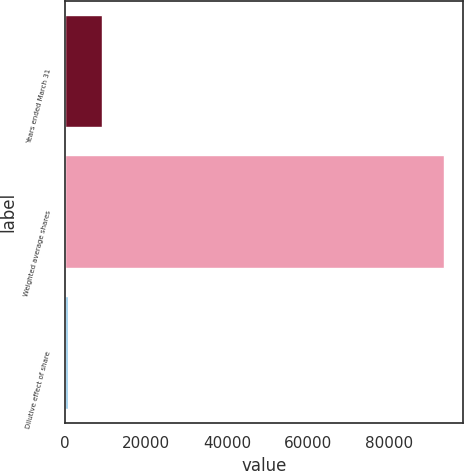Convert chart. <chart><loc_0><loc_0><loc_500><loc_500><bar_chart><fcel>Years ended March 31<fcel>Weighted average shares<fcel>Dilutive effect of share<nl><fcel>9187.8<fcel>93530.8<fcel>685<nl></chart> 